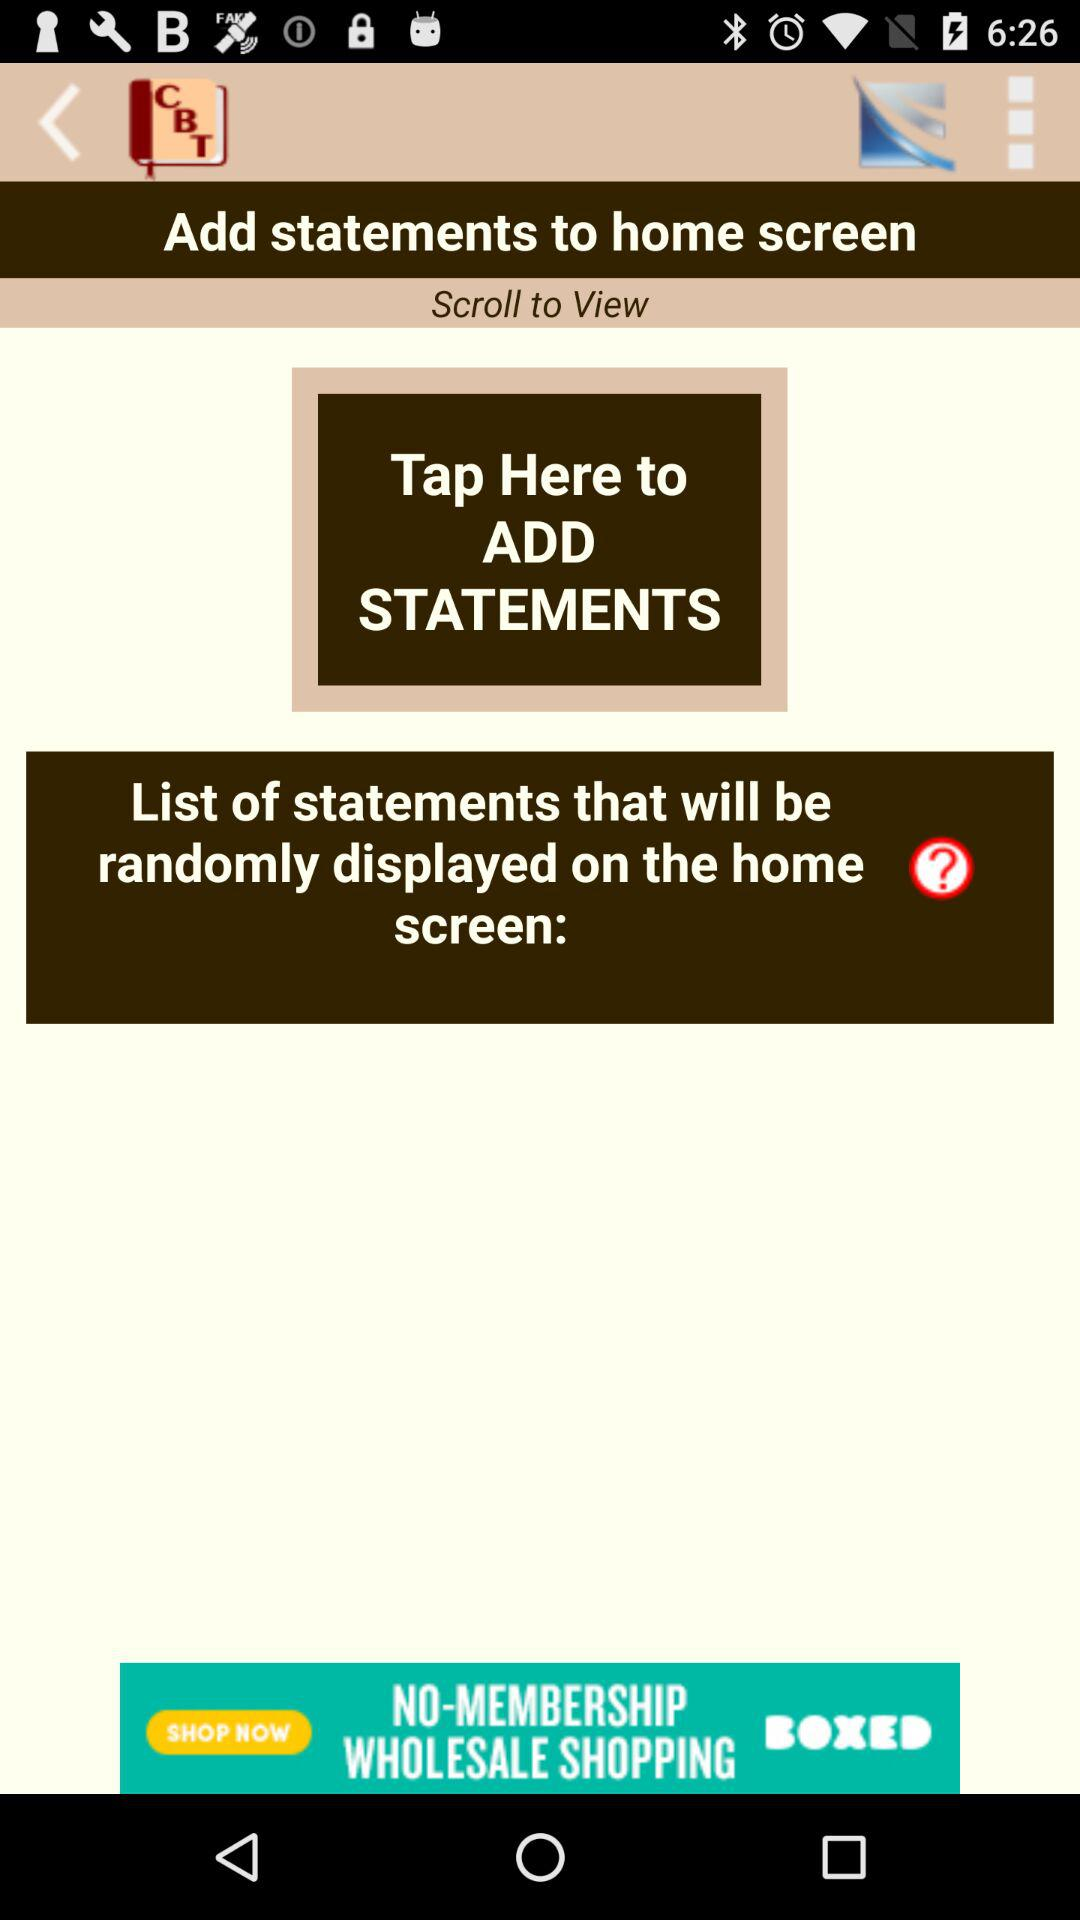What is the application name? The application name is "CBT Tools for Healthy Living". 